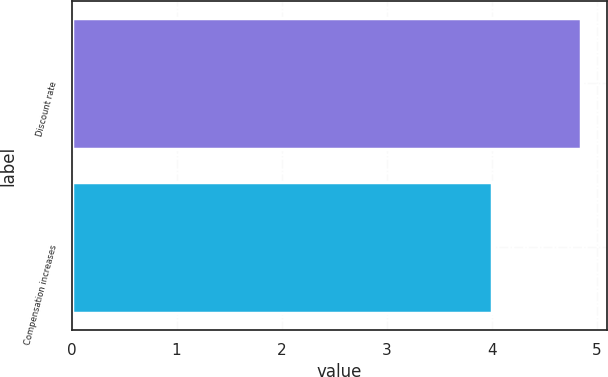Convert chart. <chart><loc_0><loc_0><loc_500><loc_500><bar_chart><fcel>Discount rate<fcel>Compensation increases<nl><fcel>4.85<fcel>4<nl></chart> 